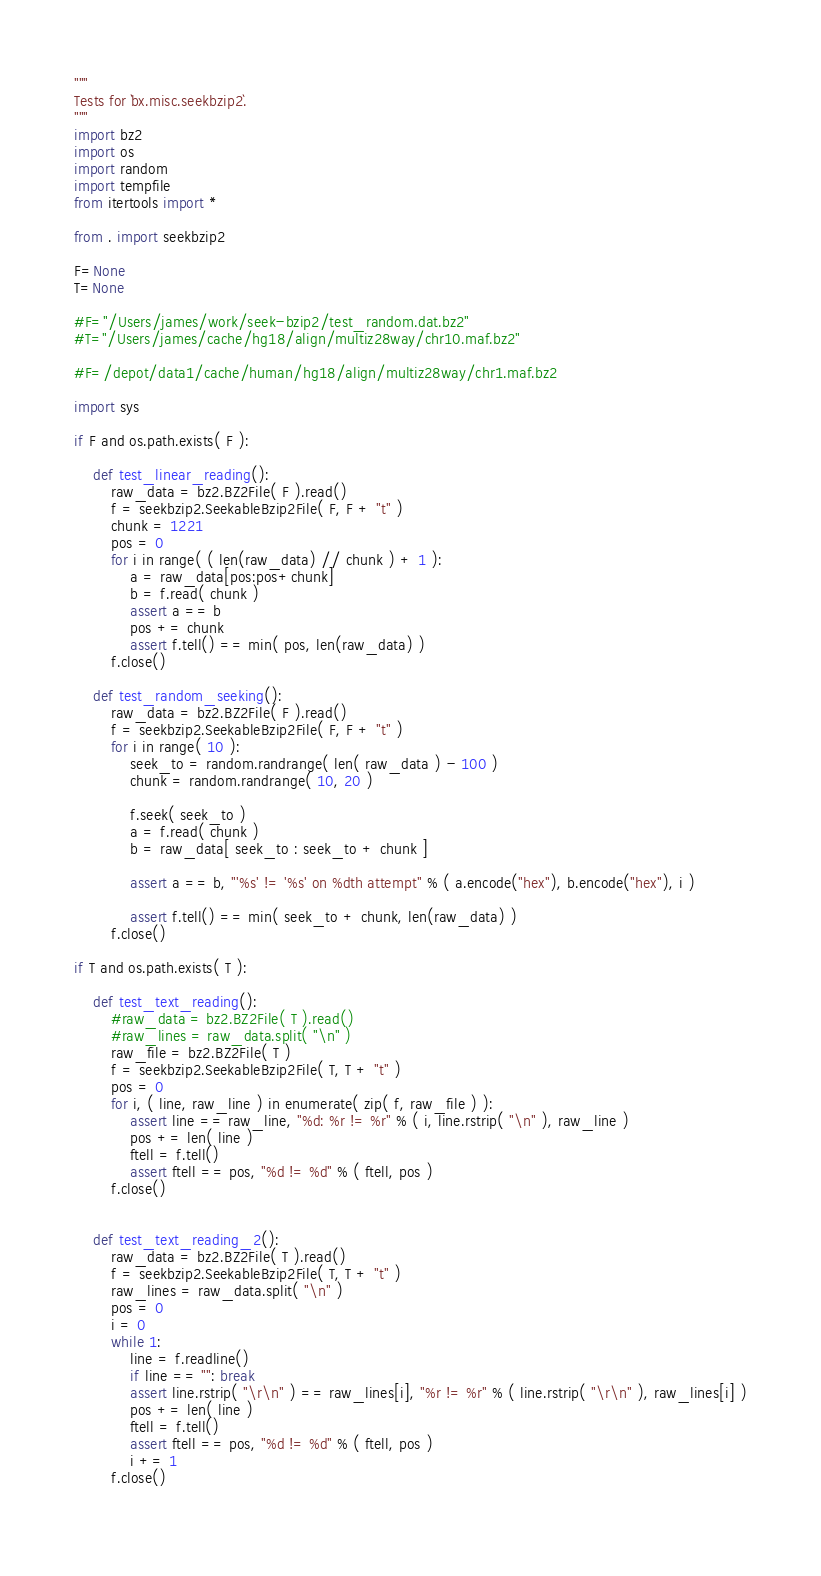Convert code to text. <code><loc_0><loc_0><loc_500><loc_500><_Python_>"""
Tests for `bx.misc.seekbzip2`.
"""
import bz2
import os
import random
import tempfile
from itertools import *

from . import seekbzip2

F=None
T=None

#F="/Users/james/work/seek-bzip2/test_random.dat.bz2"
#T="/Users/james/cache/hg18/align/multiz28way/chr10.maf.bz2"

#F=/depot/data1/cache/human/hg18/align/multiz28way/chr1.maf.bz2

import sys

if F and os.path.exists( F ):

    def test_linear_reading():
        raw_data = bz2.BZ2File( F ).read()
        f = seekbzip2.SeekableBzip2File( F, F + "t" )
        chunk = 1221
        pos = 0
        for i in range( ( len(raw_data) // chunk ) + 1 ):
            a = raw_data[pos:pos+chunk]
            b = f.read( chunk )
            assert a == b
            pos += chunk
            assert f.tell() == min( pos, len(raw_data) )
        f.close()
        
    def test_random_seeking():
        raw_data = bz2.BZ2File( F ).read()
        f = seekbzip2.SeekableBzip2File( F, F + "t" )
        for i in range( 10 ):
            seek_to = random.randrange( len( raw_data ) - 100 )
            chunk = random.randrange( 10, 20 )

            f.seek( seek_to )
            a = f.read( chunk )
            b = raw_data[ seek_to : seek_to + chunk ]
        
            assert a == b, "'%s' != '%s' on %dth attempt" % ( a.encode("hex"), b.encode("hex"), i )

            assert f.tell() == min( seek_to + chunk, len(raw_data) )
        f.close()
            
if T and os.path.exists( T ):
       
    def test_text_reading():
        #raw_data = bz2.BZ2File( T ).read()
        #raw_lines = raw_data.split( "\n" )
        raw_file = bz2.BZ2File( T )
        f = seekbzip2.SeekableBzip2File( T, T + "t" )
        pos = 0
        for i, ( line, raw_line ) in enumerate( zip( f, raw_file ) ):
            assert line == raw_line, "%d: %r != %r" % ( i, line.rstrip( "\n" ), raw_line )
            pos += len( line )
            ftell = f.tell()
            assert ftell == pos, "%d != %d" % ( ftell, pos )
        f.close()
        
  
    def test_text_reading_2():
        raw_data = bz2.BZ2File( T ).read()
        f = seekbzip2.SeekableBzip2File( T, T + "t" )
        raw_lines = raw_data.split( "\n" )
        pos = 0
        i = 0
        while 1:
            line = f.readline()
            if line == "": break
            assert line.rstrip( "\r\n" ) == raw_lines[i], "%r != %r" % ( line.rstrip( "\r\n" ), raw_lines[i] )
            pos += len( line )
            ftell = f.tell()
            assert ftell == pos, "%d != %d" % ( ftell, pos )  
            i += 1    
        f.close()
        
</code> 